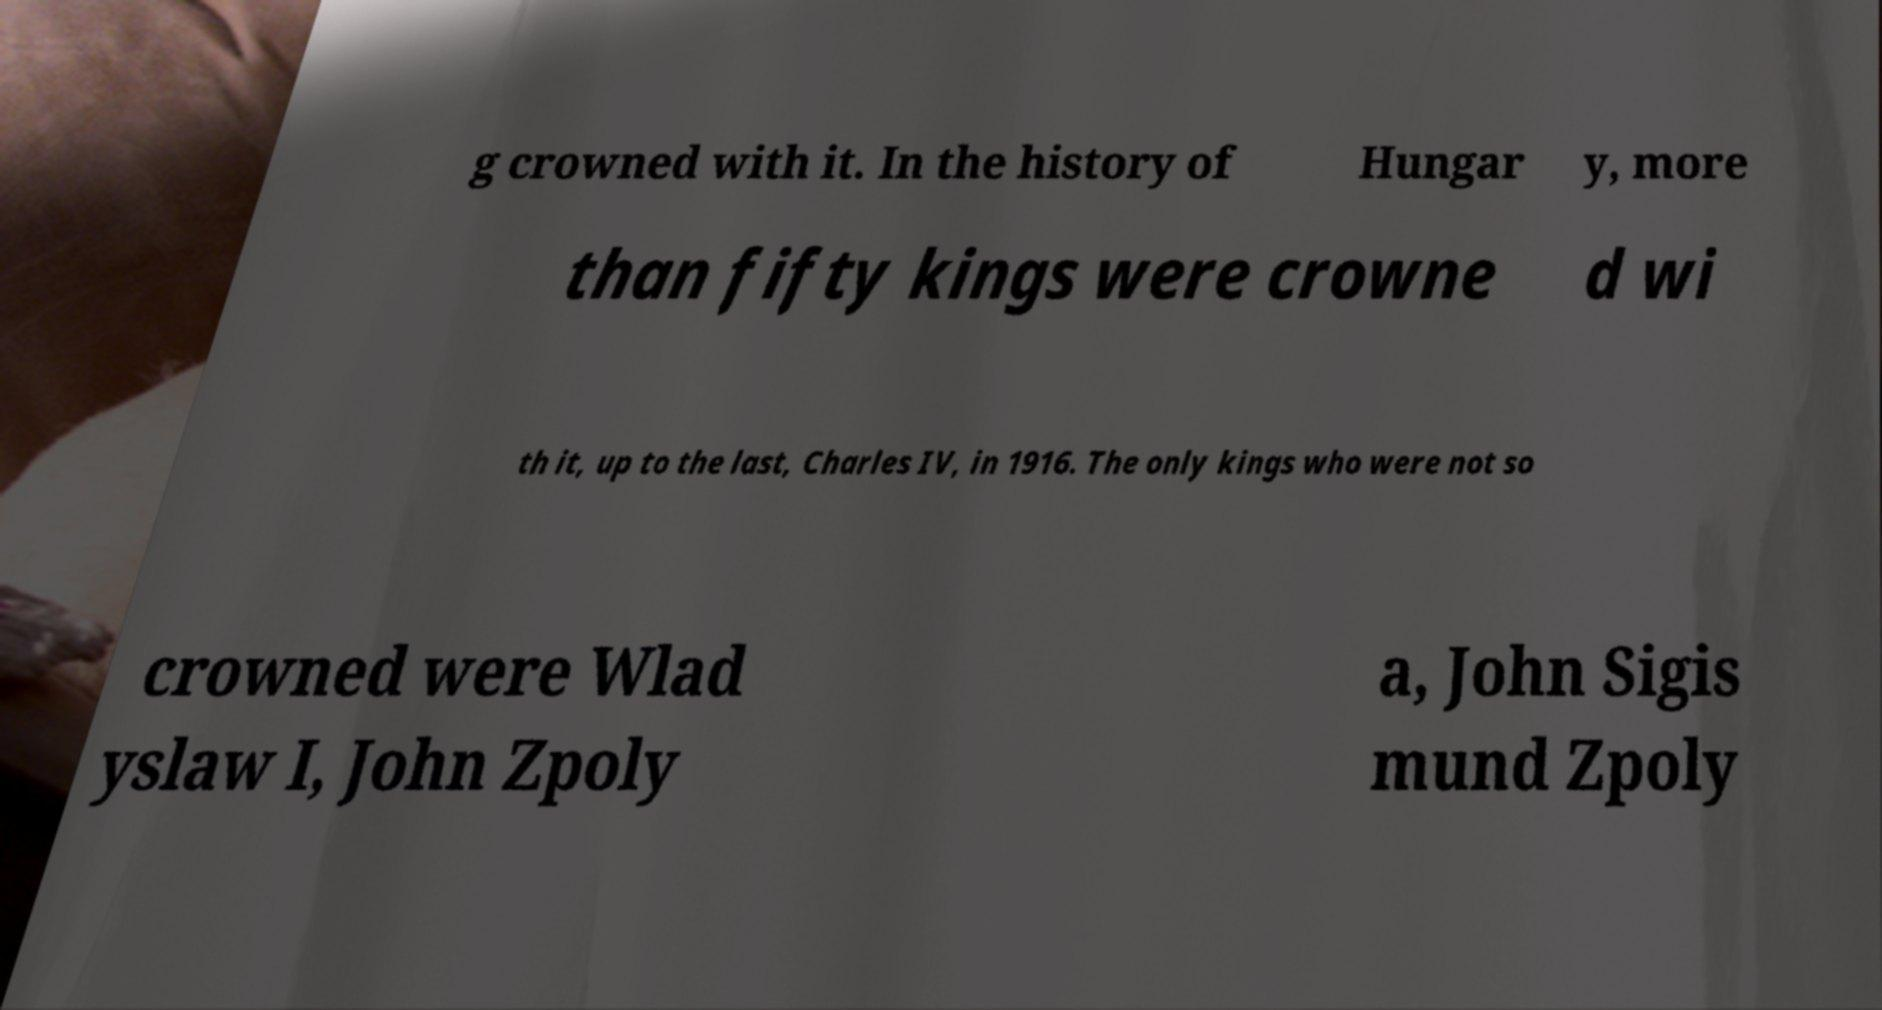For documentation purposes, I need the text within this image transcribed. Could you provide that? g crowned with it. In the history of Hungar y, more than fifty kings were crowne d wi th it, up to the last, Charles IV, in 1916. The only kings who were not so crowned were Wlad yslaw I, John Zpoly a, John Sigis mund Zpoly 